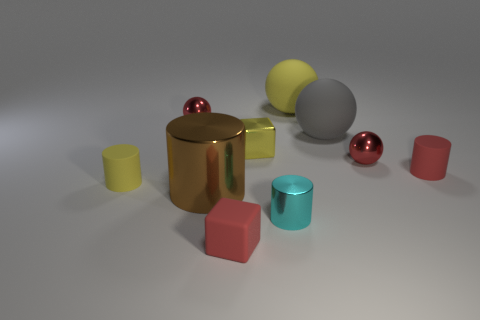Subtract 1 spheres. How many spheres are left? 3 Subtract all yellow cylinders. Subtract all gray cubes. How many cylinders are left? 3 Subtract all cylinders. How many objects are left? 6 Subtract 1 yellow cubes. How many objects are left? 9 Subtract all yellow shiny things. Subtract all yellow spheres. How many objects are left? 8 Add 7 red rubber cylinders. How many red rubber cylinders are left? 8 Add 4 brown metal cylinders. How many brown metal cylinders exist? 5 